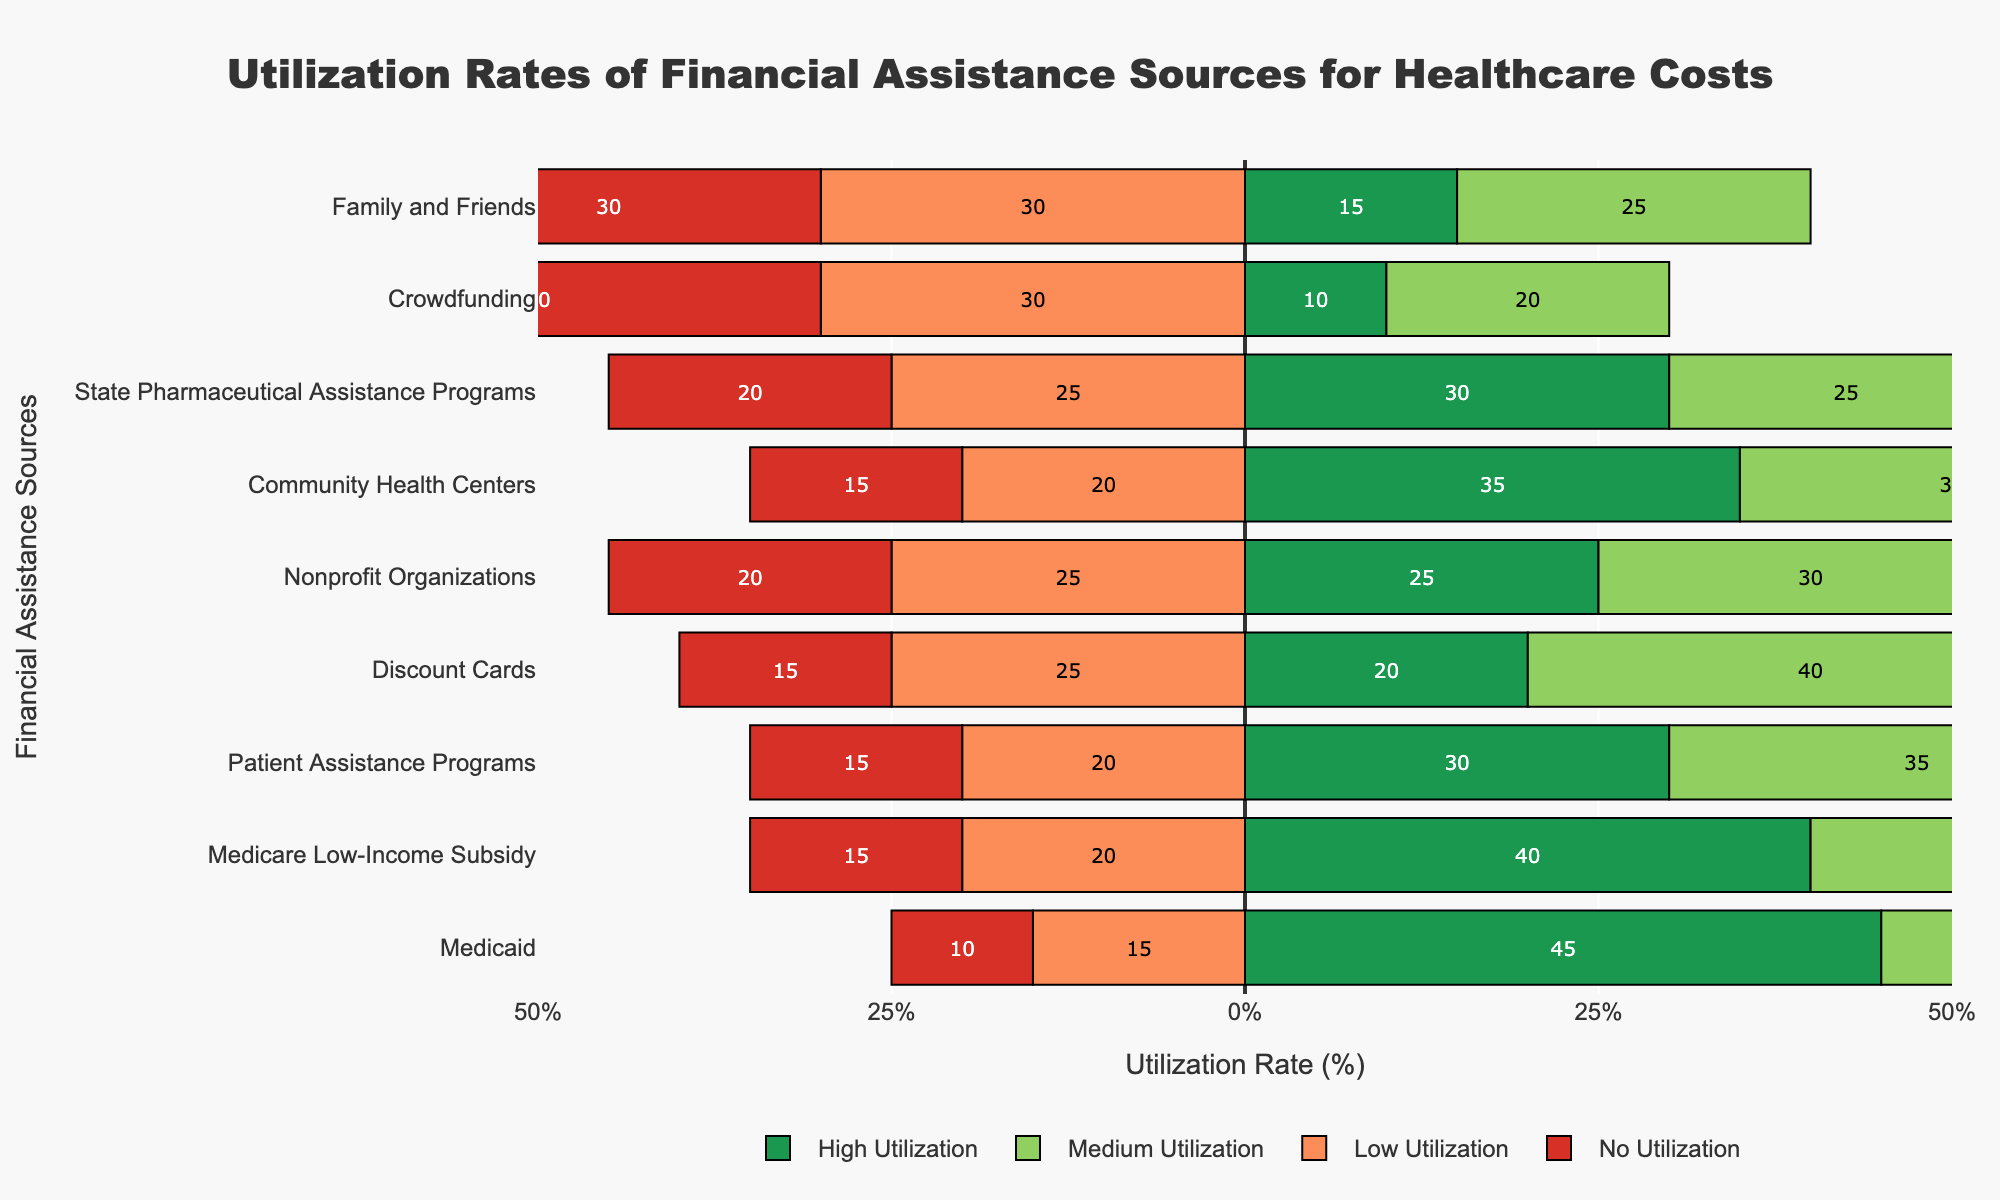Which source has the highest high utilization rate? The green bars in the chart represent high utilization. The longest green bar belongs to Medicaid, indicating it has the highest high utilization rate at 45%.
Answer: Medicaid Which source has the lowest high utilization rate? Again, focusing on the green bars, the shortest green bar belongs to Crowdfunding, indicating it has the lowest high utilization rate at 10%.
Answer: Crowdfunding Which sources have equal medium utilization rates, and what is that rate? The medium utilization rates are represented by the lighter green bars. Both Nonprofit Organizations and Community Health Centers have medium utilization rates of 30%.
Answer: Nonprofit Organizations, Community Health Centers What is the difference between high and medium utilization rates for Discount Cards? High utilization rate for Discount Cards is 20%, and medium utilization rate is 40%. The difference is 40% - 20% = 20%.
Answer: 20% Rank the sources by the lowest no utilization rate. The red bars represent no utilization. The shortest red bar belongs to Medicaid (10%), followed by Medicare Low-Income Subsidy (15%), Patient Assistance Programs (15%), Discount Cards (15%), Community Health Centers (15%), State Pharmaceutical Assistance Programs (20%), Nonprofit Organizations (20%), Family and Friends (30%), and Crowdfunding (40%).
Answer: Medicaid, Medicare Low-Income Subsidy, Patient Assistance Programs, Discount Cards, Community Health Centers, State Pharmaceutical Assistance Programs, Nonprofit Organizations, Family and Friends, Crowdfunding Which source has the highest no utilization rate and what is it? The longest red bar in the chart indicates the highest no utilization rate, which belongs to Crowdfunding at 40%.
Answer: Crowdfunding What is the sum of low and no utilization rates for Family and Friends? Low utilization rate for Family and Friends is 30%, and no utilization rate is also 30%. Summing them up, 30% + 30% = 60%.
Answer: 60% Compare the high utilization rates of Medicaid and Medicare Low-Income Subsidy. Which one is higher and by how much? High utilization rate for Medicaid is 45% and for Medicare Low-Income Subsidy it is 40%. The difference is 45% - 40% = 5%.
Answer: Medicaid by 5% Which categories have a low utilization rate of 25%, and what are those categories? The length of the orange bar indicating a rate of 25% can be seen in Discount Cards, Nonprofit Organizations, State Pharmaceutical Assistance Programs, and Family and Friends.
Answer: Discount Cards, Nonprofit Organizations, State Pharmaceutical Assistance Programs, Family and Friends 